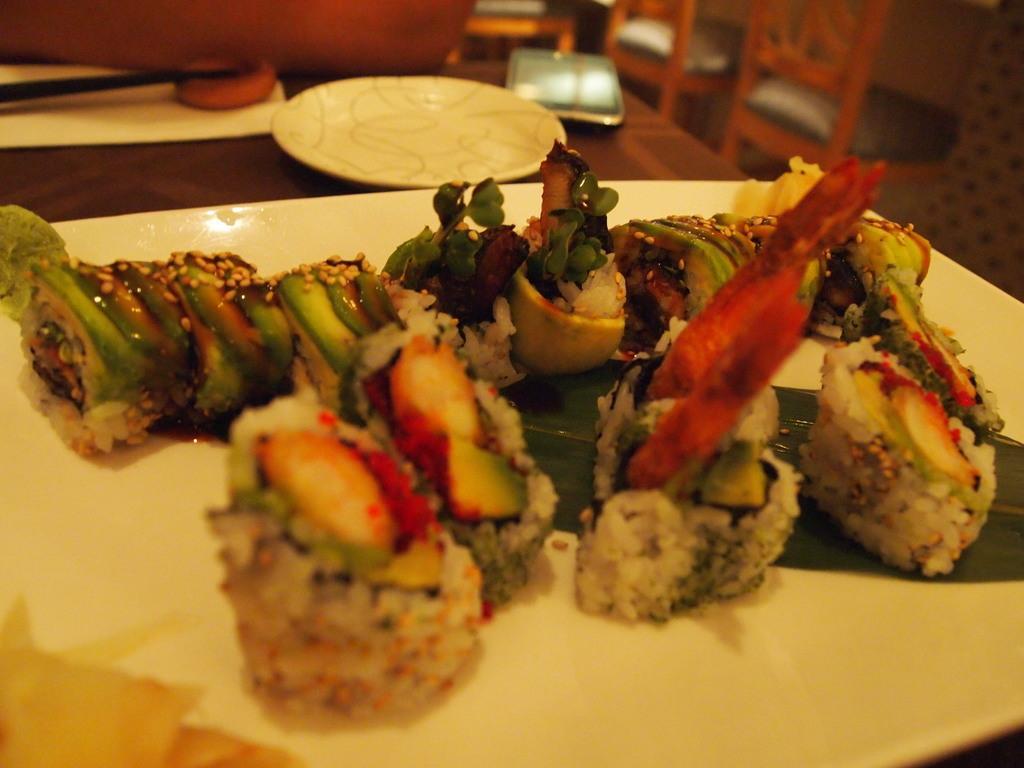Can you describe this image briefly? In this picture we can see food in the plate and in the background we can see a plate, mobile, chairs, wall. 